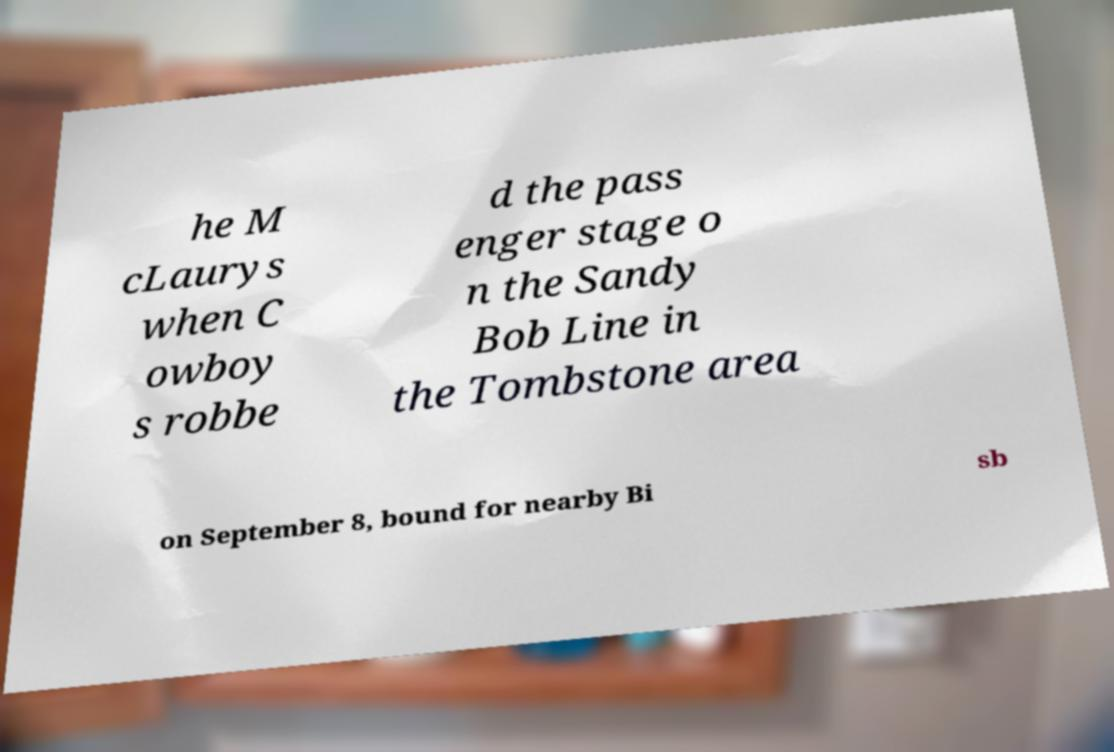What messages or text are displayed in this image? I need them in a readable, typed format. he M cLaurys when C owboy s robbe d the pass enger stage o n the Sandy Bob Line in the Tombstone area on September 8, bound for nearby Bi sb 